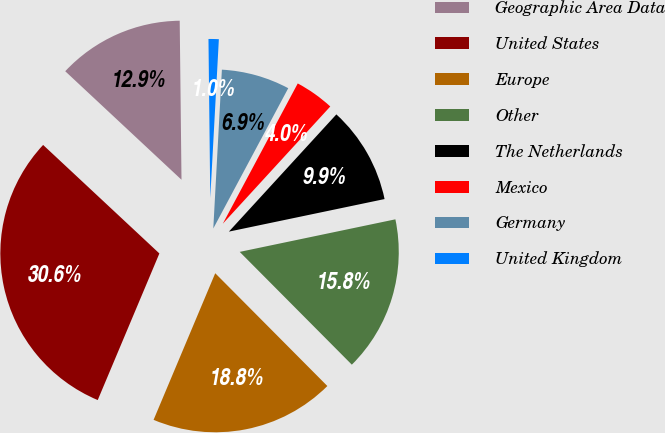<chart> <loc_0><loc_0><loc_500><loc_500><pie_chart><fcel>Geographic Area Data<fcel>United States<fcel>Europe<fcel>Other<fcel>The Netherlands<fcel>Mexico<fcel>Germany<fcel>United Kingdom<nl><fcel>12.87%<fcel>30.62%<fcel>18.79%<fcel>15.83%<fcel>9.91%<fcel>4.0%<fcel>6.95%<fcel>1.04%<nl></chart> 